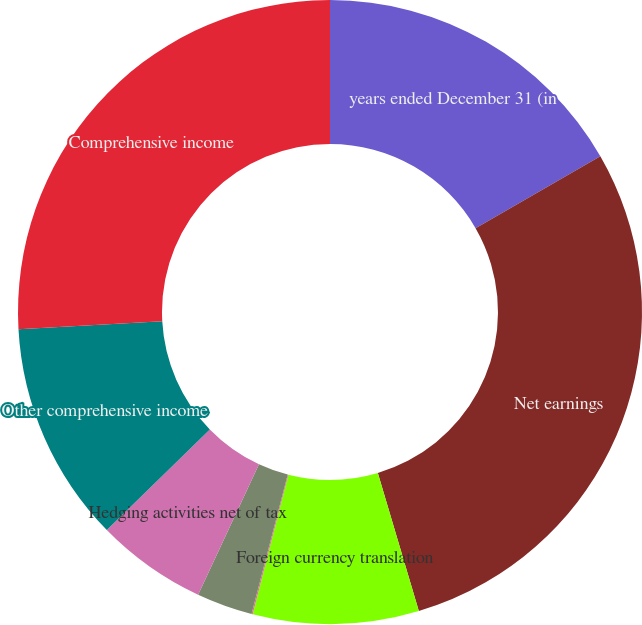<chart> <loc_0><loc_0><loc_500><loc_500><pie_chart><fcel>years ended December 31 (in<fcel>Net earnings<fcel>Foreign currency translation<fcel>Pension and post-employment<fcel>Unrealized gains (losses) on<fcel>Hedging activities net of tax<fcel>Other comprehensive income<fcel>Comprehensive income<nl><fcel>16.68%<fcel>28.72%<fcel>8.58%<fcel>0.06%<fcel>2.9%<fcel>5.74%<fcel>11.43%<fcel>25.88%<nl></chart> 